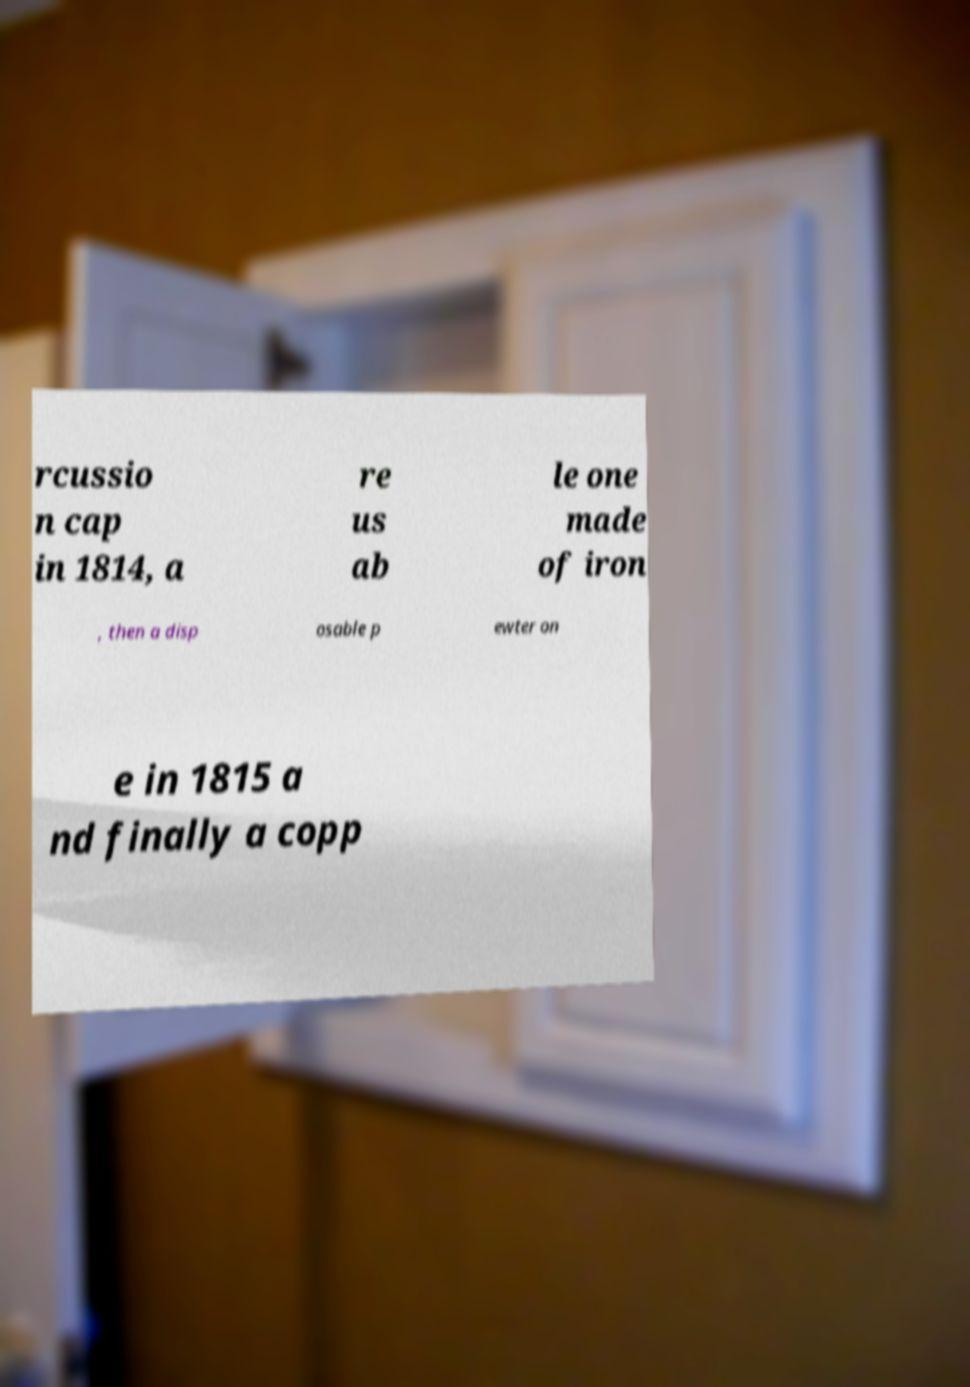Could you extract and type out the text from this image? rcussio n cap in 1814, a re us ab le one made of iron , then a disp osable p ewter on e in 1815 a nd finally a copp 